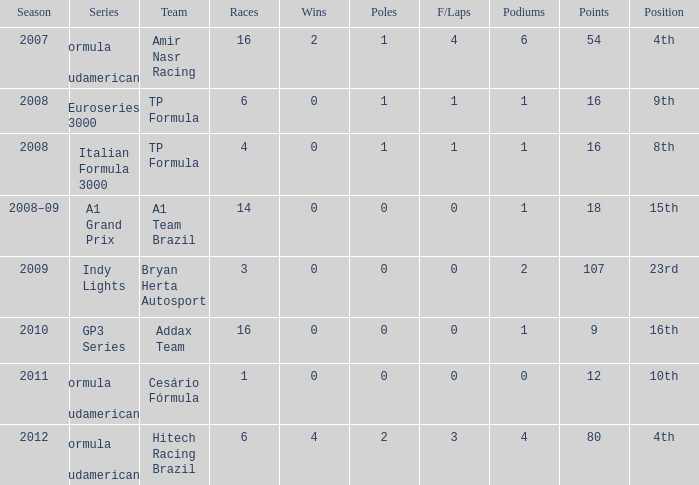Write the full table. {'header': ['Season', 'Series', 'Team', 'Races', 'Wins', 'Poles', 'F/Laps', 'Podiums', 'Points', 'Position'], 'rows': [['2007', 'Formula 3 Sudamericana', 'Amir Nasr Racing', '16', '2', '1', '4', '6', '54', '4th'], ['2008', 'Euroseries 3000', 'TP Formula', '6', '0', '1', '1', '1', '16', '9th'], ['2008', 'Italian Formula 3000', 'TP Formula', '4', '0', '1', '1', '1', '16', '8th'], ['2008–09', 'A1 Grand Prix', 'A1 Team Brazil', '14', '0', '0', '0', '1', '18', '15th'], ['2009', 'Indy Lights', 'Bryan Herta Autosport', '3', '0', '0', '0', '2', '107', '23rd'], ['2010', 'GP3 Series', 'Addax Team', '16', '0', '0', '0', '1', '9', '16th'], ['2011', 'Formula 3 Sudamericana', 'Cesário Fórmula', '1', '0', '0', '0', '0', '12', '10th'], ['2012', 'Formula 3 Sudamericana', 'Hitech Racing Brazil', '6', '4', '2', '3', '4', '80', '4th']]} What unit did he compete with in the gp3 series? Addax Team. 